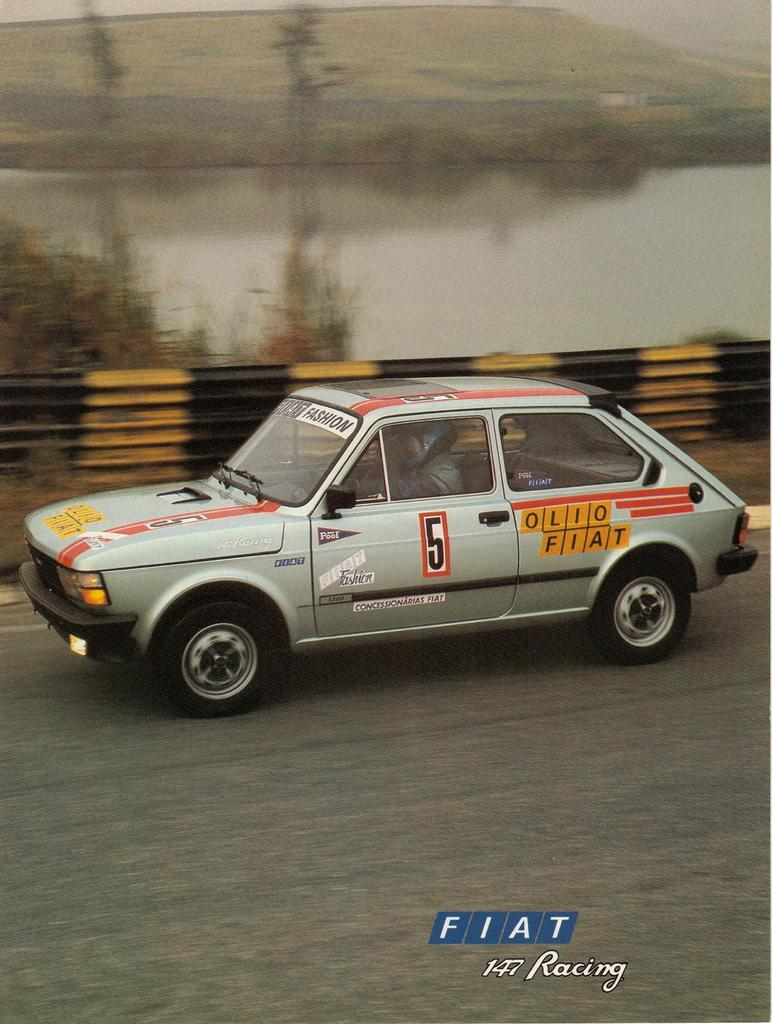What is the main subject of the image? There is a car on the road in the image. Who or what is inside the car? A person is seated in the car. What is located beside the car? There is a fence and trees beside the car. What can be seen in the background of the image? There is water visible in the image. What type of root can be seen growing from the car in the image? There is no root growing from the car in the image. What kind of food is the person in the car eating? The provided facts do not mention any food, so we cannot determine what the person is eating in the image. 